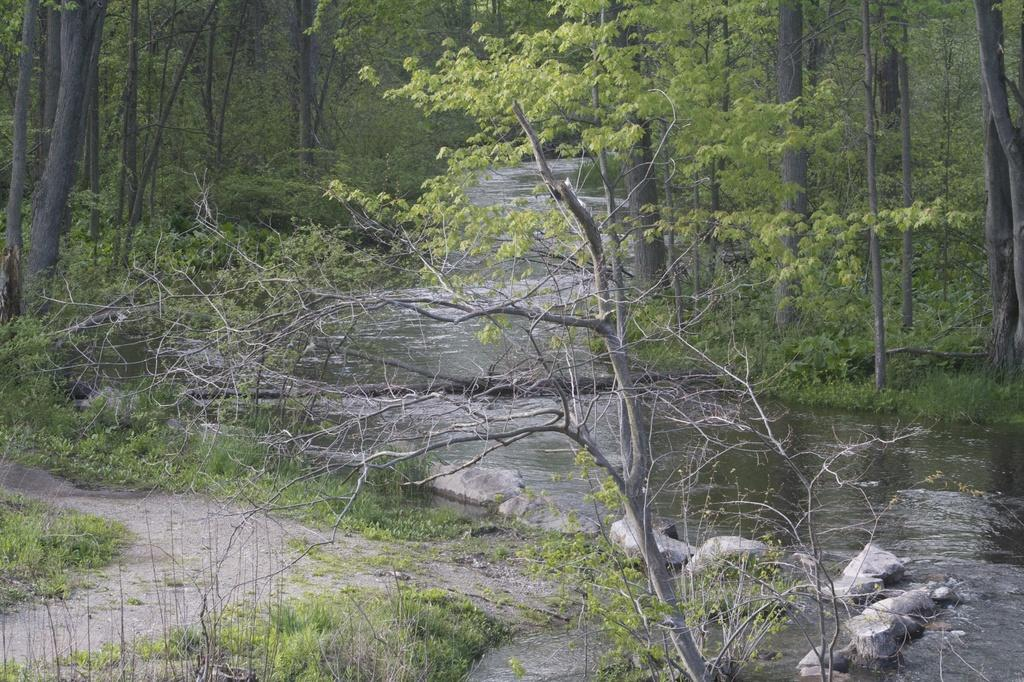What type of natural feature is present in the image? There is a river in the image. What other elements can be seen in the image? There are stones, grass, and trees in the image. How many owls can be seen in the image? There are no owls present in the image. What is the size of the earth in the image? The image does not depict the earth, so its size cannot be determined. 